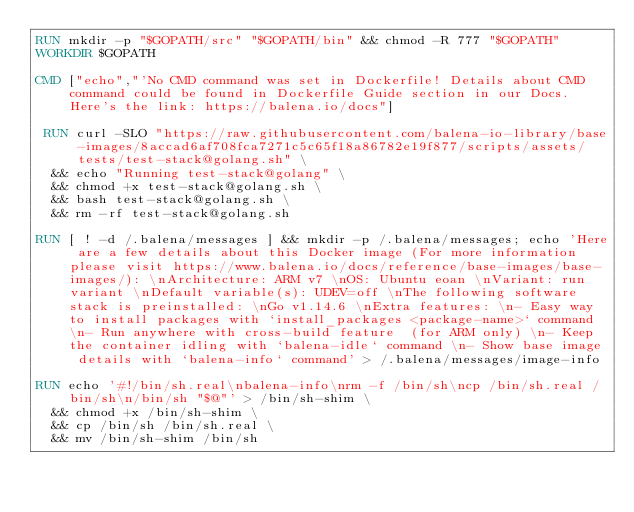<code> <loc_0><loc_0><loc_500><loc_500><_Dockerfile_>RUN mkdir -p "$GOPATH/src" "$GOPATH/bin" && chmod -R 777 "$GOPATH"
WORKDIR $GOPATH

CMD ["echo","'No CMD command was set in Dockerfile! Details about CMD command could be found in Dockerfile Guide section in our Docs. Here's the link: https://balena.io/docs"]

 RUN curl -SLO "https://raw.githubusercontent.com/balena-io-library/base-images/8accad6af708fca7271c5c65f18a86782e19f877/scripts/assets/tests/test-stack@golang.sh" \
  && echo "Running test-stack@golang" \
  && chmod +x test-stack@golang.sh \
  && bash test-stack@golang.sh \
  && rm -rf test-stack@golang.sh 

RUN [ ! -d /.balena/messages ] && mkdir -p /.balena/messages; echo 'Here are a few details about this Docker image (For more information please visit https://www.balena.io/docs/reference/base-images/base-images/): \nArchitecture: ARM v7 \nOS: Ubuntu eoan \nVariant: run variant \nDefault variable(s): UDEV=off \nThe following software stack is preinstalled: \nGo v1.14.6 \nExtra features: \n- Easy way to install packages with `install_packages <package-name>` command \n- Run anywhere with cross-build feature  (for ARM only) \n- Keep the container idling with `balena-idle` command \n- Show base image details with `balena-info` command' > /.balena/messages/image-info

RUN echo '#!/bin/sh.real\nbalena-info\nrm -f /bin/sh\ncp /bin/sh.real /bin/sh\n/bin/sh "$@"' > /bin/sh-shim \
	&& chmod +x /bin/sh-shim \
	&& cp /bin/sh /bin/sh.real \
	&& mv /bin/sh-shim /bin/sh</code> 